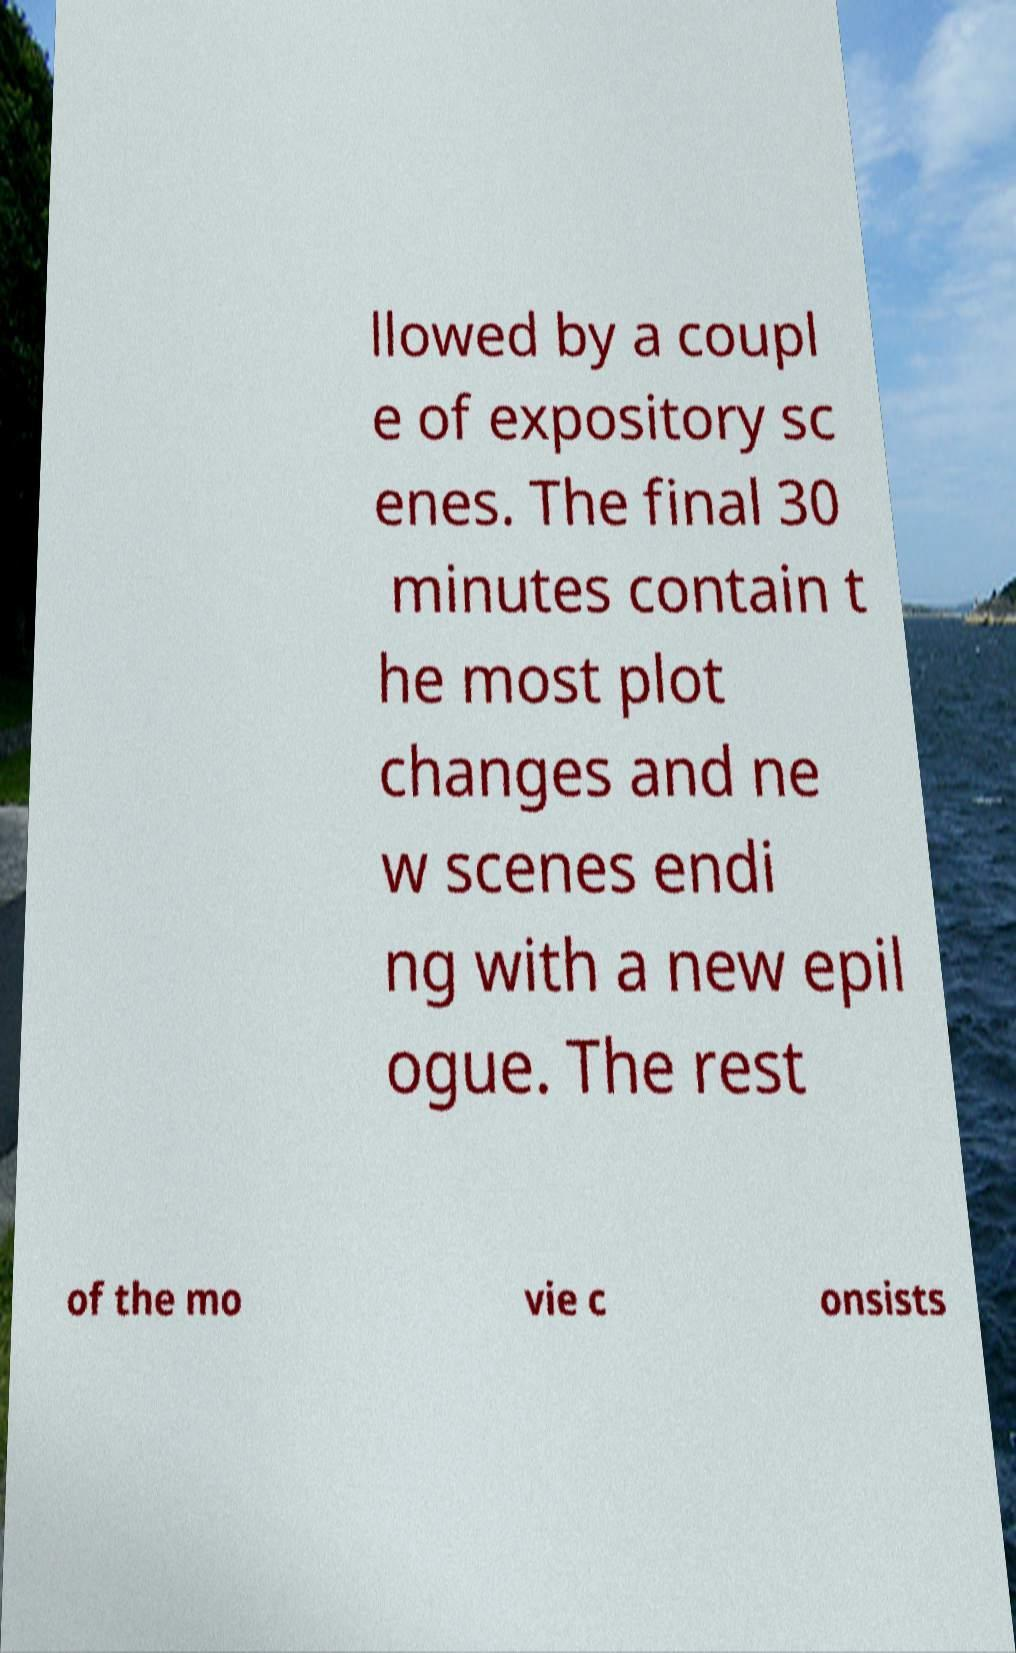I need the written content from this picture converted into text. Can you do that? llowed by a coupl e of expository sc enes. The final 30 minutes contain t he most plot changes and ne w scenes endi ng with a new epil ogue. The rest of the mo vie c onsists 